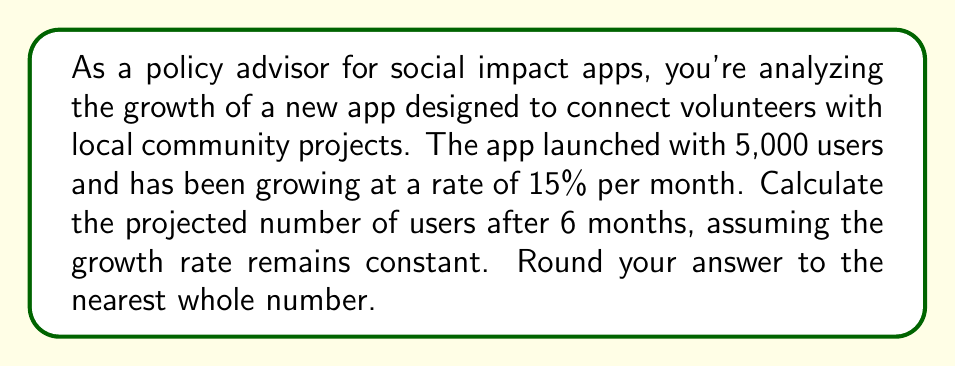Provide a solution to this math problem. To solve this problem, we'll use the compound growth formula:

$$A = P(1 + r)^n$$

Where:
$A$ = Final amount
$P$ = Initial principal balance
$r$ = Growth rate (as a decimal)
$n$ = Number of time periods

Given:
$P = 5,000$ (initial users)
$r = 0.15$ (15% monthly growth rate)
$n = 6$ (months)

Let's substitute these values into the formula:

$$A = 5,000(1 + 0.15)^6$$

Now, let's solve step-by-step:

1) First, calculate $(1 + 0.15)^6$:
   $$(1.15)^6 \approx 2.3131$$

2) Multiply this result by the initial number of users:
   $$5,000 \times 2.3131 \approx 11,565.5$$

3) Round to the nearest whole number:
   $$11,565.5 \approx 11,566$$
Answer: 11,566 users 